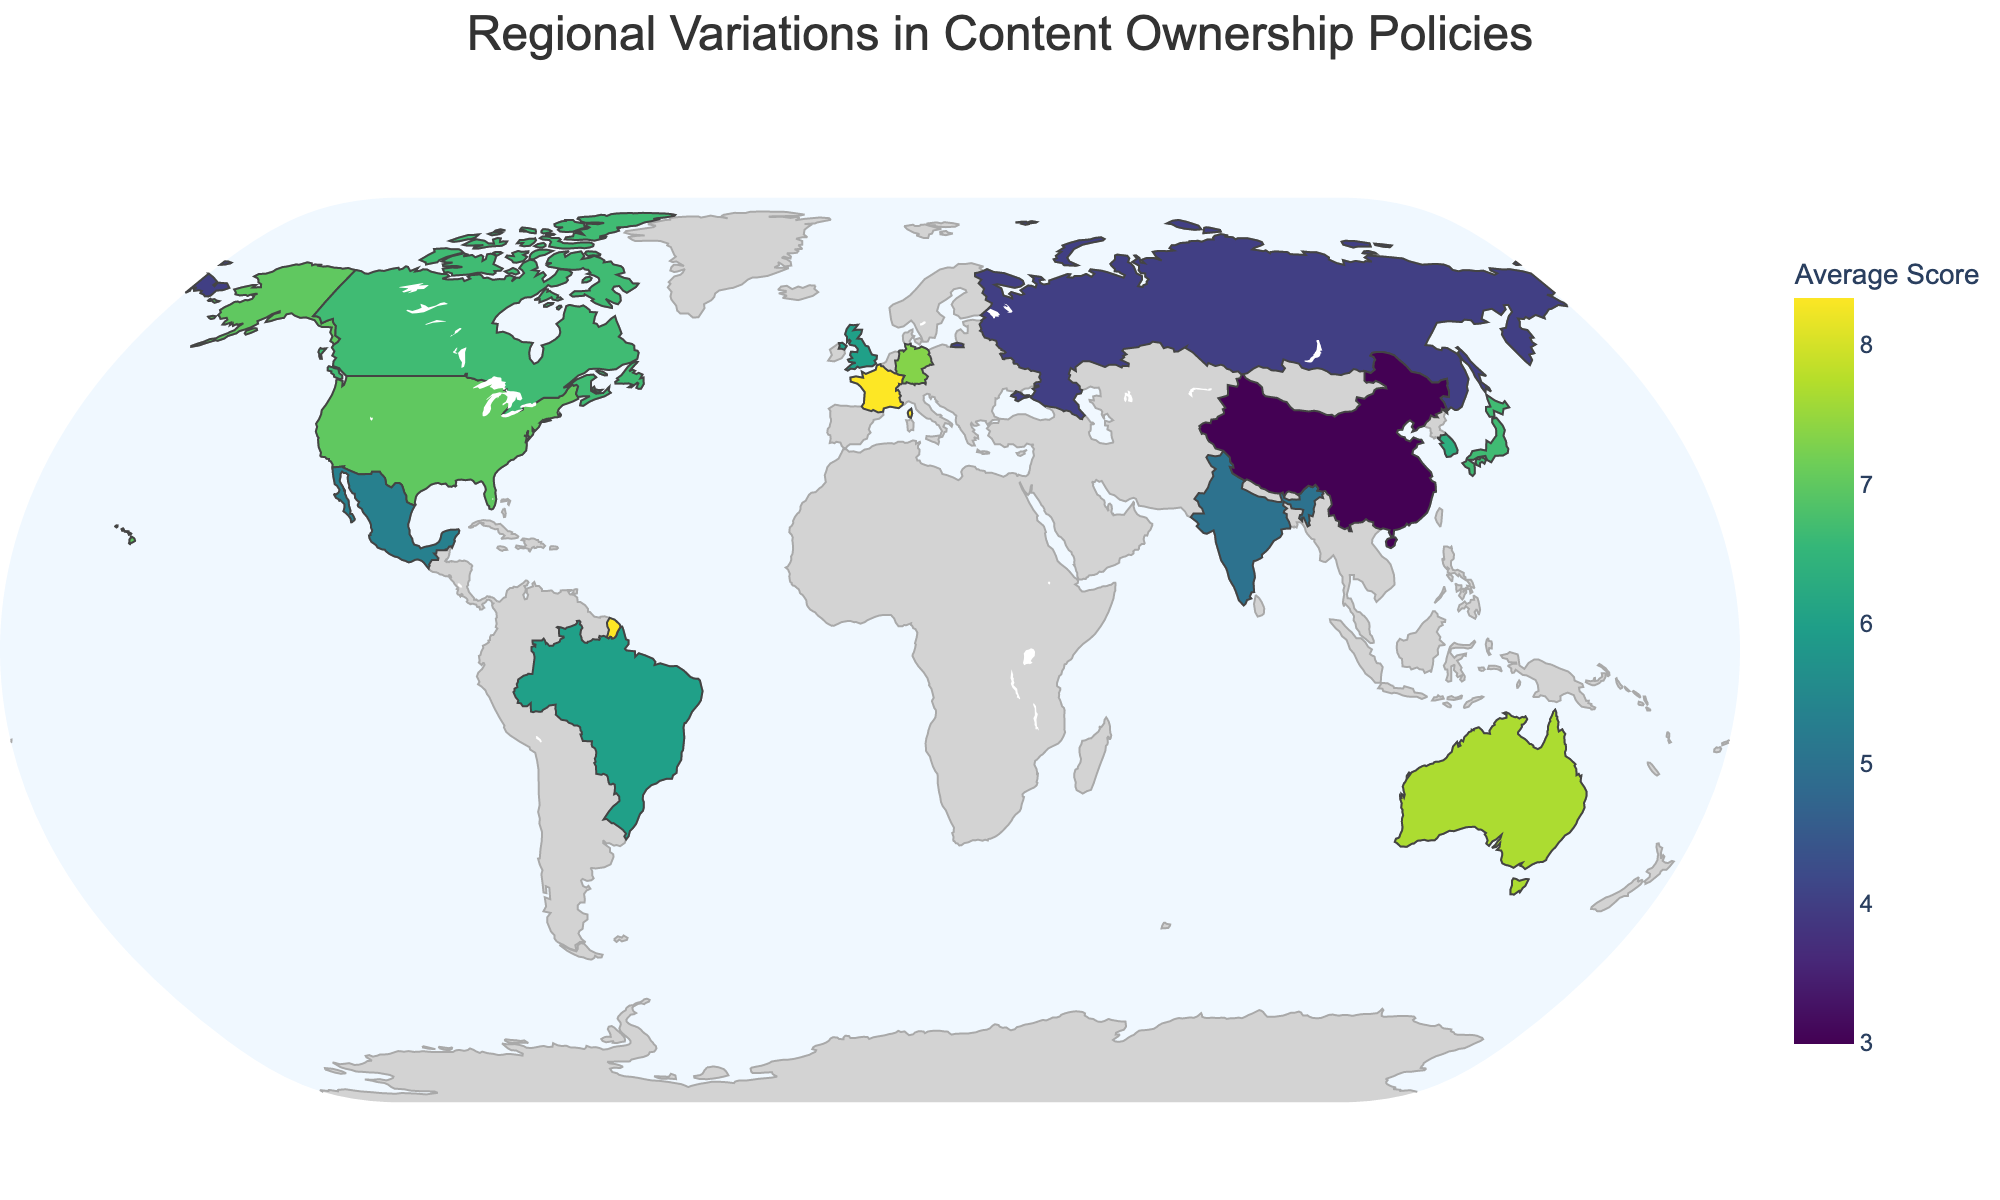How strict are content ownership policies in the United States compared to China? By looking at the "Content Ownership Policy Strictness" scores in the hover data, the United States has a score of 8 while China has a score of 3, indicating that content ownership policies are significantly stricter in the United States.
Answer: The United States has stricter policies than China Which region has the highest average score, and what platform does it represent? The region with the highest average score can be identified by looking for the highest value of "avg_score" in the figure. The European Union and France both have an average score of 8.33. The platform for the European Union is Facebook, and for France, it's WhatsApp.
Answer: European Union (Facebook) and France (WhatsApp) What's the difference in the Data Portability Rating between Russia and the European Union? Looking at the hover data for "Data Portability Rating," Russia has a score of 3 while the European Union has a score of 8. The difference is 8 - 3 = 5.
Answer: 5 How does the average score of South Korea compare to that of Singapore? According to the hover data, South Korea has an average score of 6.33, and Singapore has an average score of 6.33 as well. Thus, their average scores are equal.
Answer: They have the same average score Which region has the lowest Influencer Rights Score, and how does that impact its overall average score compared to other regions? The lowest Influencer Rights Score is observed in China with a score of 4. This region also has one of the lowest average scores, which is 3.0. This low Influencer Rights Score brings down China's overall average score compared to other regions.
Answer: China, contributes to a lower overall average score What is the title of the geographic plot? The title can be found on the top of the figure. It is designed to summarize the key focus of the plot. Here, the title reads "Regional Variations in Content Ownership Policies."
Answer: Regional Variations in Content Ownership Policies How are regions with an average score of 7 spread geographically? By analyzing the color scale and the plotted regions, regions with an average score of 7 include Canada, Japan, and South Korea. These regions are geographically spread across North America, Asia, and East Asia.
Answer: Canada, Japan, and South Korea are geographically spread across North America and Asia Which region and platform have the same scores for all three categories: Content Ownership Policy Strictness, Influencer Rights Score, and Data Portability Rating? By examining the hover data for each region, Australia (YouTube) has the same score for all three categories, each being 8.
Answer: Australia (YouTube) What is the most common Content Ownership Policy Strictness score among the listed regions? By looking through the hover data for each region, we see that the scores range between 3 to 9. The most frequently occurring score is 7, appearing in multiple regions such as the United Kingdom, Canada, South Korea, and others.
Answer: 7 